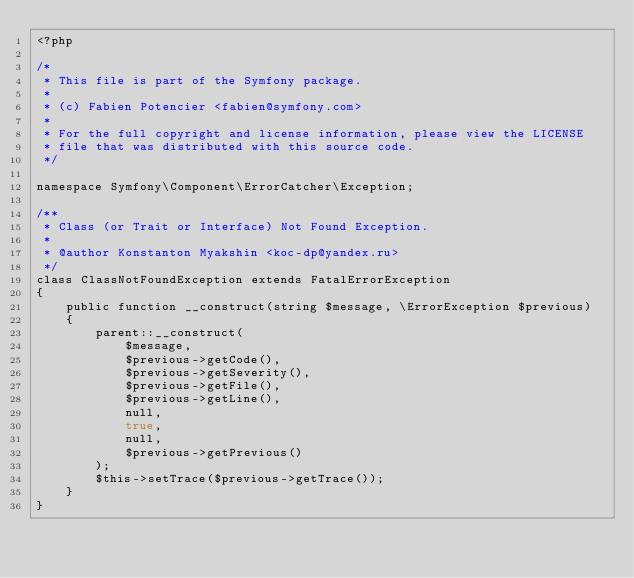Convert code to text. <code><loc_0><loc_0><loc_500><loc_500><_PHP_><?php

/*
 * This file is part of the Symfony package.
 *
 * (c) Fabien Potencier <fabien@symfony.com>
 *
 * For the full copyright and license information, please view the LICENSE
 * file that was distributed with this source code.
 */

namespace Symfony\Component\ErrorCatcher\Exception;

/**
 * Class (or Trait or Interface) Not Found Exception.
 *
 * @author Konstanton Myakshin <koc-dp@yandex.ru>
 */
class ClassNotFoundException extends FatalErrorException
{
    public function __construct(string $message, \ErrorException $previous)
    {
        parent::__construct(
            $message,
            $previous->getCode(),
            $previous->getSeverity(),
            $previous->getFile(),
            $previous->getLine(),
            null,
            true,
            null,
            $previous->getPrevious()
        );
        $this->setTrace($previous->getTrace());
    }
}
</code> 